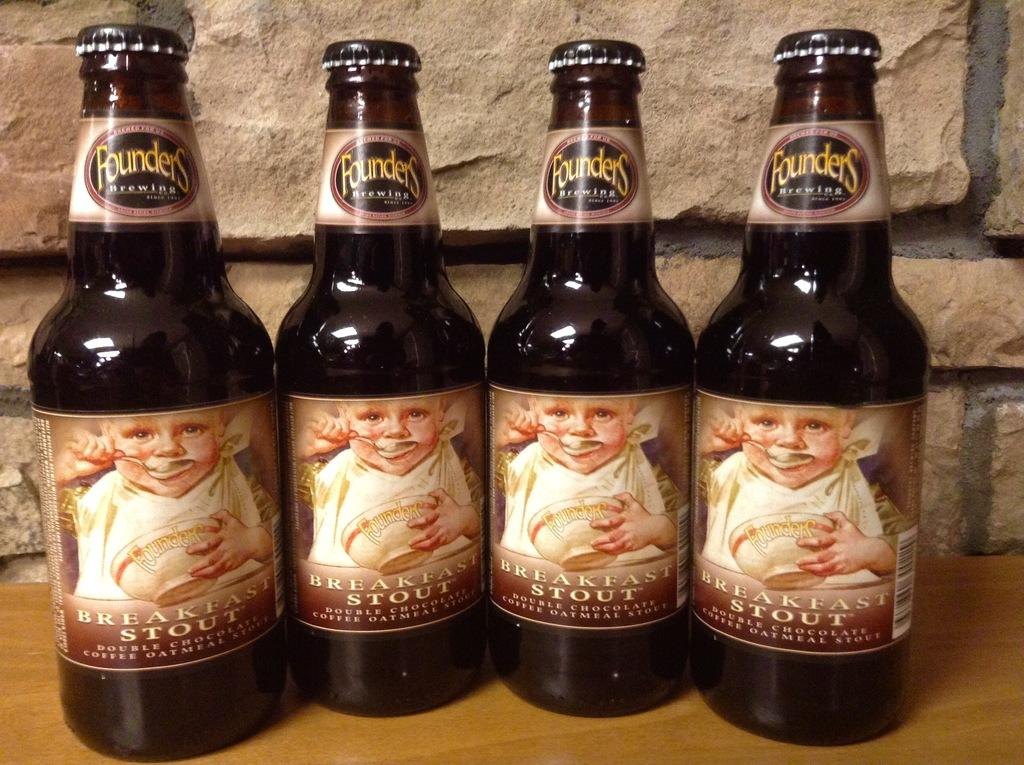<image>
Summarize the visual content of the image. Four different bottles from the company Founders Brewing 